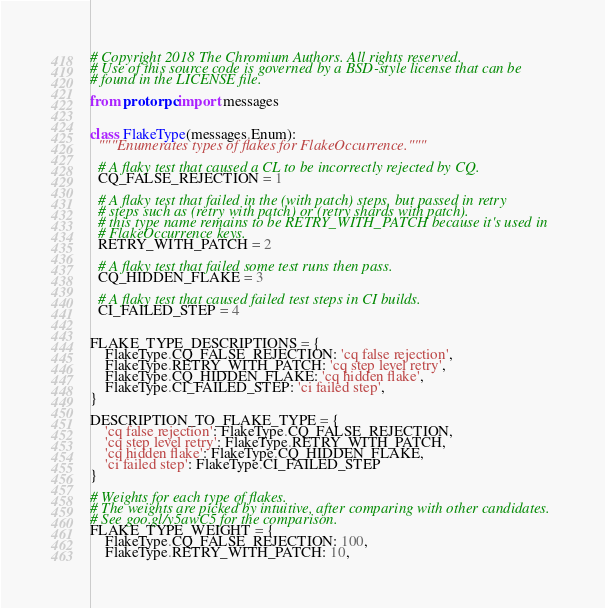Convert code to text. <code><loc_0><loc_0><loc_500><loc_500><_Python_># Copyright 2018 The Chromium Authors. All rights reserved.
# Use of this source code is governed by a BSD-style license that can be
# found in the LICENSE file.

from protorpc import messages


class FlakeType(messages.Enum):
  """Enumerates types of flakes for FlakeOccurrence."""

  # A flaky test that caused a CL to be incorrectly rejected by CQ.
  CQ_FALSE_REJECTION = 1

  # A flaky test that failed in the (with patch) steps, but passed in retry
  # steps such as (retry with patch) or (retry shards with patch).
  # this type name remains to be RETRY_WITH_PATCH because it's used in
  # FlakeOccurrence keys.
  RETRY_WITH_PATCH = 2

  # A flaky test that failed some test runs then pass.
  CQ_HIDDEN_FLAKE = 3

  # A flaky test that caused failed test steps in CI builds.
  CI_FAILED_STEP = 4


FLAKE_TYPE_DESCRIPTIONS = {
    FlakeType.CQ_FALSE_REJECTION: 'cq false rejection',
    FlakeType.RETRY_WITH_PATCH: 'cq step level retry',
    FlakeType.CQ_HIDDEN_FLAKE: 'cq hidden flake',
    FlakeType.CI_FAILED_STEP: 'ci failed step',
}

DESCRIPTION_TO_FLAKE_TYPE = {
    'cq false rejection': FlakeType.CQ_FALSE_REJECTION,
    'cq step level retry': FlakeType.RETRY_WITH_PATCH,
    'cq hidden flake': FlakeType.CQ_HIDDEN_FLAKE,
    'ci failed step': FlakeType.CI_FAILED_STEP
}

# Weights for each type of flakes.
# The weights are picked by intuitive, after comparing with other candidates.
# See goo.gl/y5awC5 for the comparison.
FLAKE_TYPE_WEIGHT = {
    FlakeType.CQ_FALSE_REJECTION: 100,
    FlakeType.RETRY_WITH_PATCH: 10,</code> 